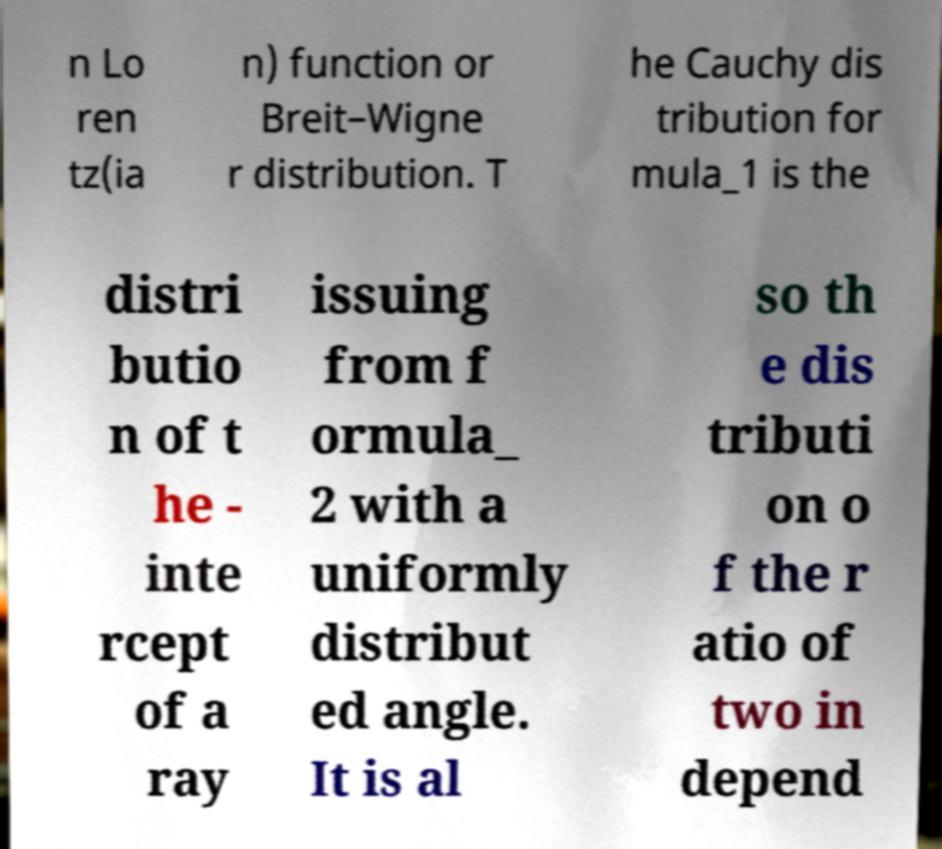Please read and relay the text visible in this image. What does it say? n Lo ren tz(ia n) function or Breit–Wigne r distribution. T he Cauchy dis tribution for mula_1 is the distri butio n of t he - inte rcept of a ray issuing from f ormula_ 2 with a uniformly distribut ed angle. It is al so th e dis tributi on o f the r atio of two in depend 